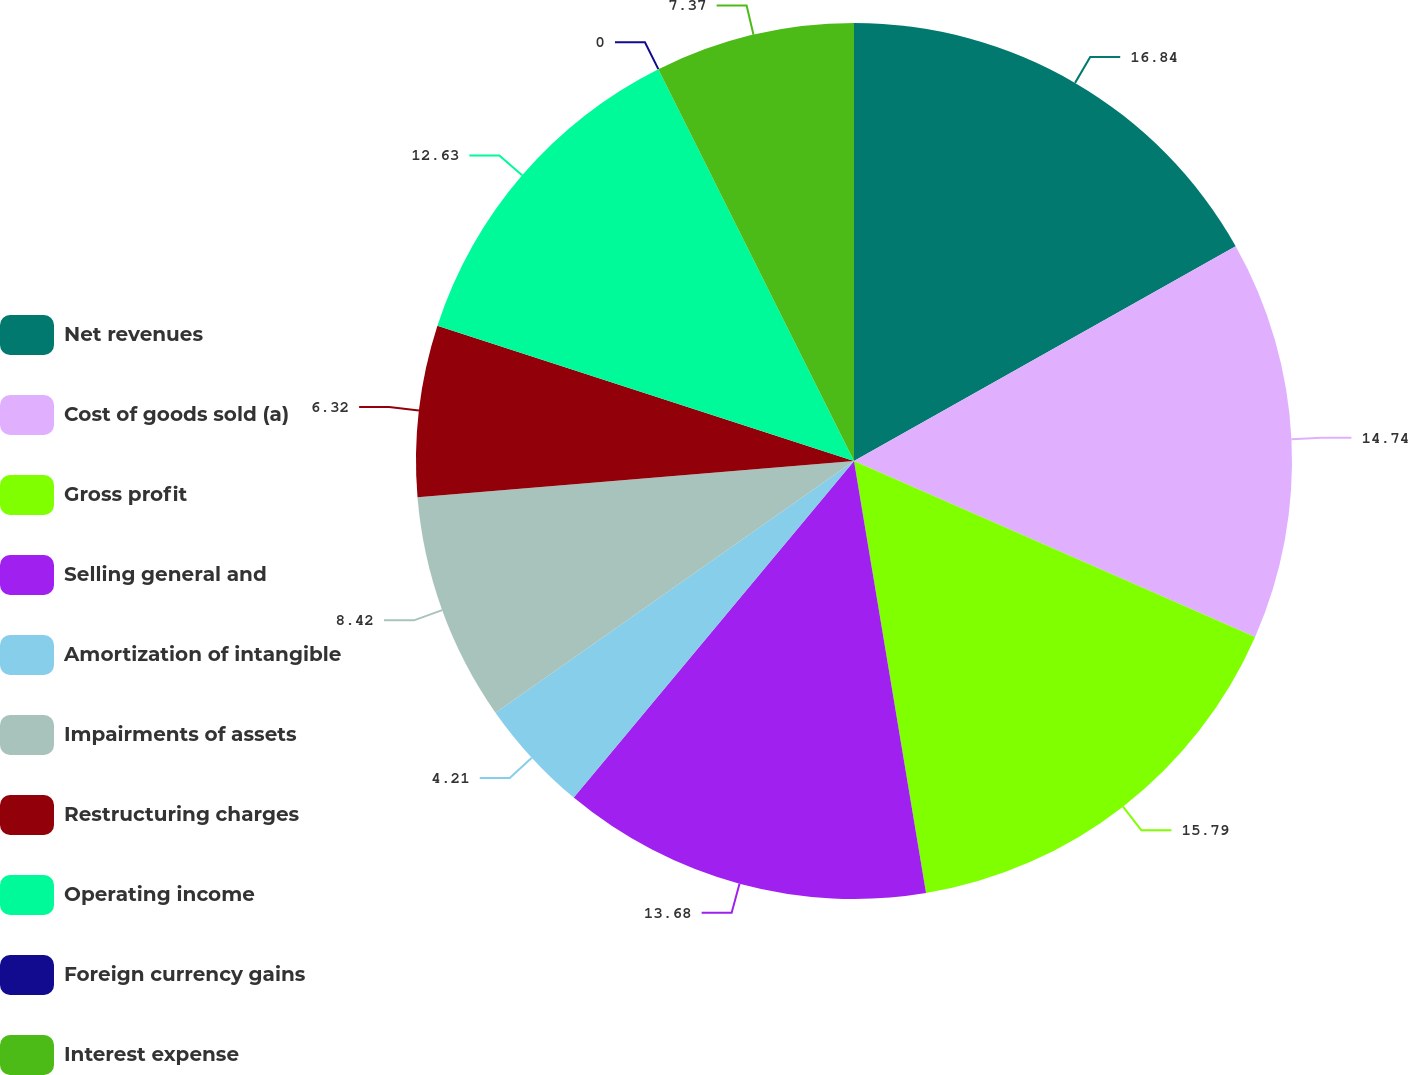<chart> <loc_0><loc_0><loc_500><loc_500><pie_chart><fcel>Net revenues<fcel>Cost of goods sold (a)<fcel>Gross profit<fcel>Selling general and<fcel>Amortization of intangible<fcel>Impairments of assets<fcel>Restructuring charges<fcel>Operating income<fcel>Foreign currency gains<fcel>Interest expense<nl><fcel>16.84%<fcel>14.74%<fcel>15.79%<fcel>13.68%<fcel>4.21%<fcel>8.42%<fcel>6.32%<fcel>12.63%<fcel>0.0%<fcel>7.37%<nl></chart> 